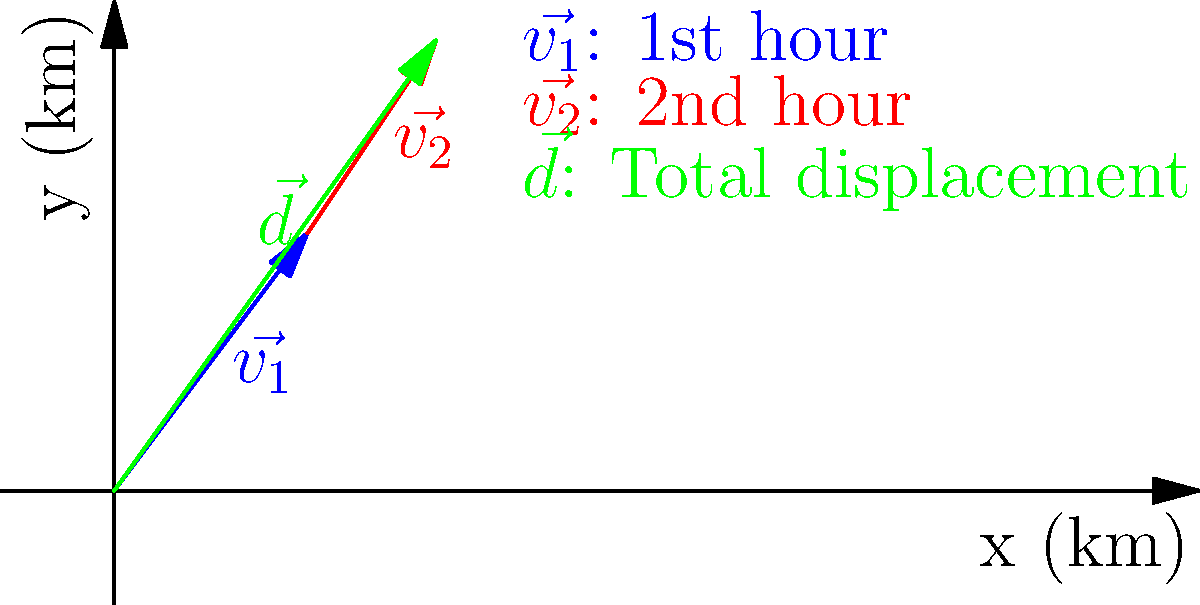A delivery truck carrying electronics travels for two hours. In the first hour, its velocity vector is $\vec{v_1} = 3\hat{i} + 4\hat{j}$ km/h, and in the second hour, its velocity vector is $\vec{v_2} = 2\hat{i} + 3\hat{j}$ km/h. What is the truck's total displacement vector $\vec{d}$? To find the total displacement vector, we need to follow these steps:

1) First, calculate the displacement for each hour:
   - For the first hour: $\vec{d_1} = \vec{v_1} \cdot 1\text{h} = (3\hat{i} + 4\hat{j})$ km
   - For the second hour: $\vec{d_2} = \vec{v_2} \cdot 1\text{h} = (2\hat{i} + 3\hat{j})$ km

2) The total displacement is the sum of these two displacements:
   $\vec{d} = \vec{d_1} + \vec{d_2} = (3\hat{i} + 4\hat{j}) + (2\hat{i} + 3\hat{j})$

3) Add the components:
   $\vec{d} = (3+2)\hat{i} + (4+3)\hat{j} = 5\hat{i} + 7\hat{j}$

Therefore, the total displacement vector is $\vec{d} = 5\hat{i} + 7\hat{j}$ km.
Answer: $5\hat{i} + 7\hat{j}$ km 